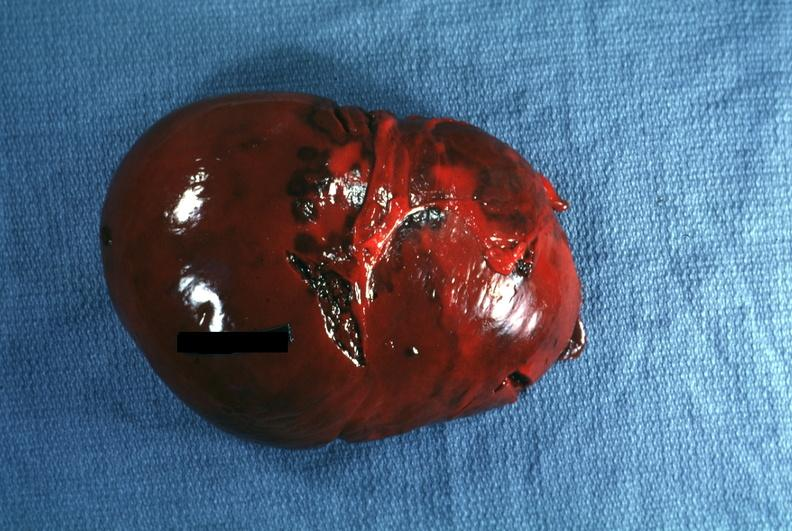s external view several capsule lacerations seen seen?
Answer the question using a single word or phrase. Yes 